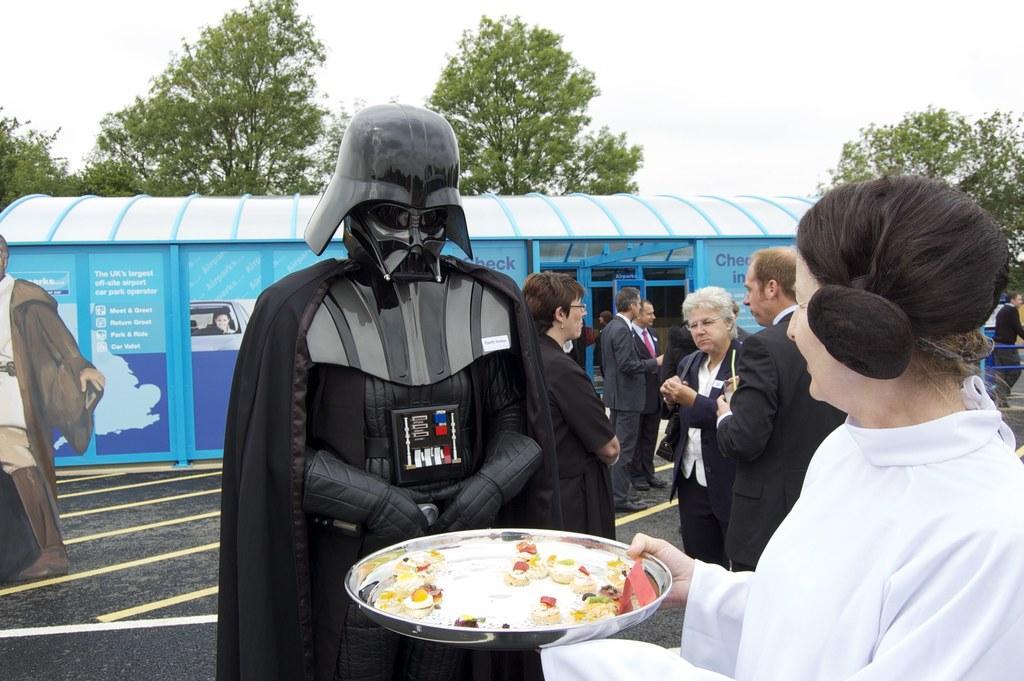Please provide a concise description of this image. In the center of the image, we can see a person wearing costume and on the right, there is a lady wearing a coat and holding a plate containing food. In the background, there are people and are wearing coats and we can see a shed, some trees, rods and there is a board. At the bottom, there is a road and at the top, there is sky. 